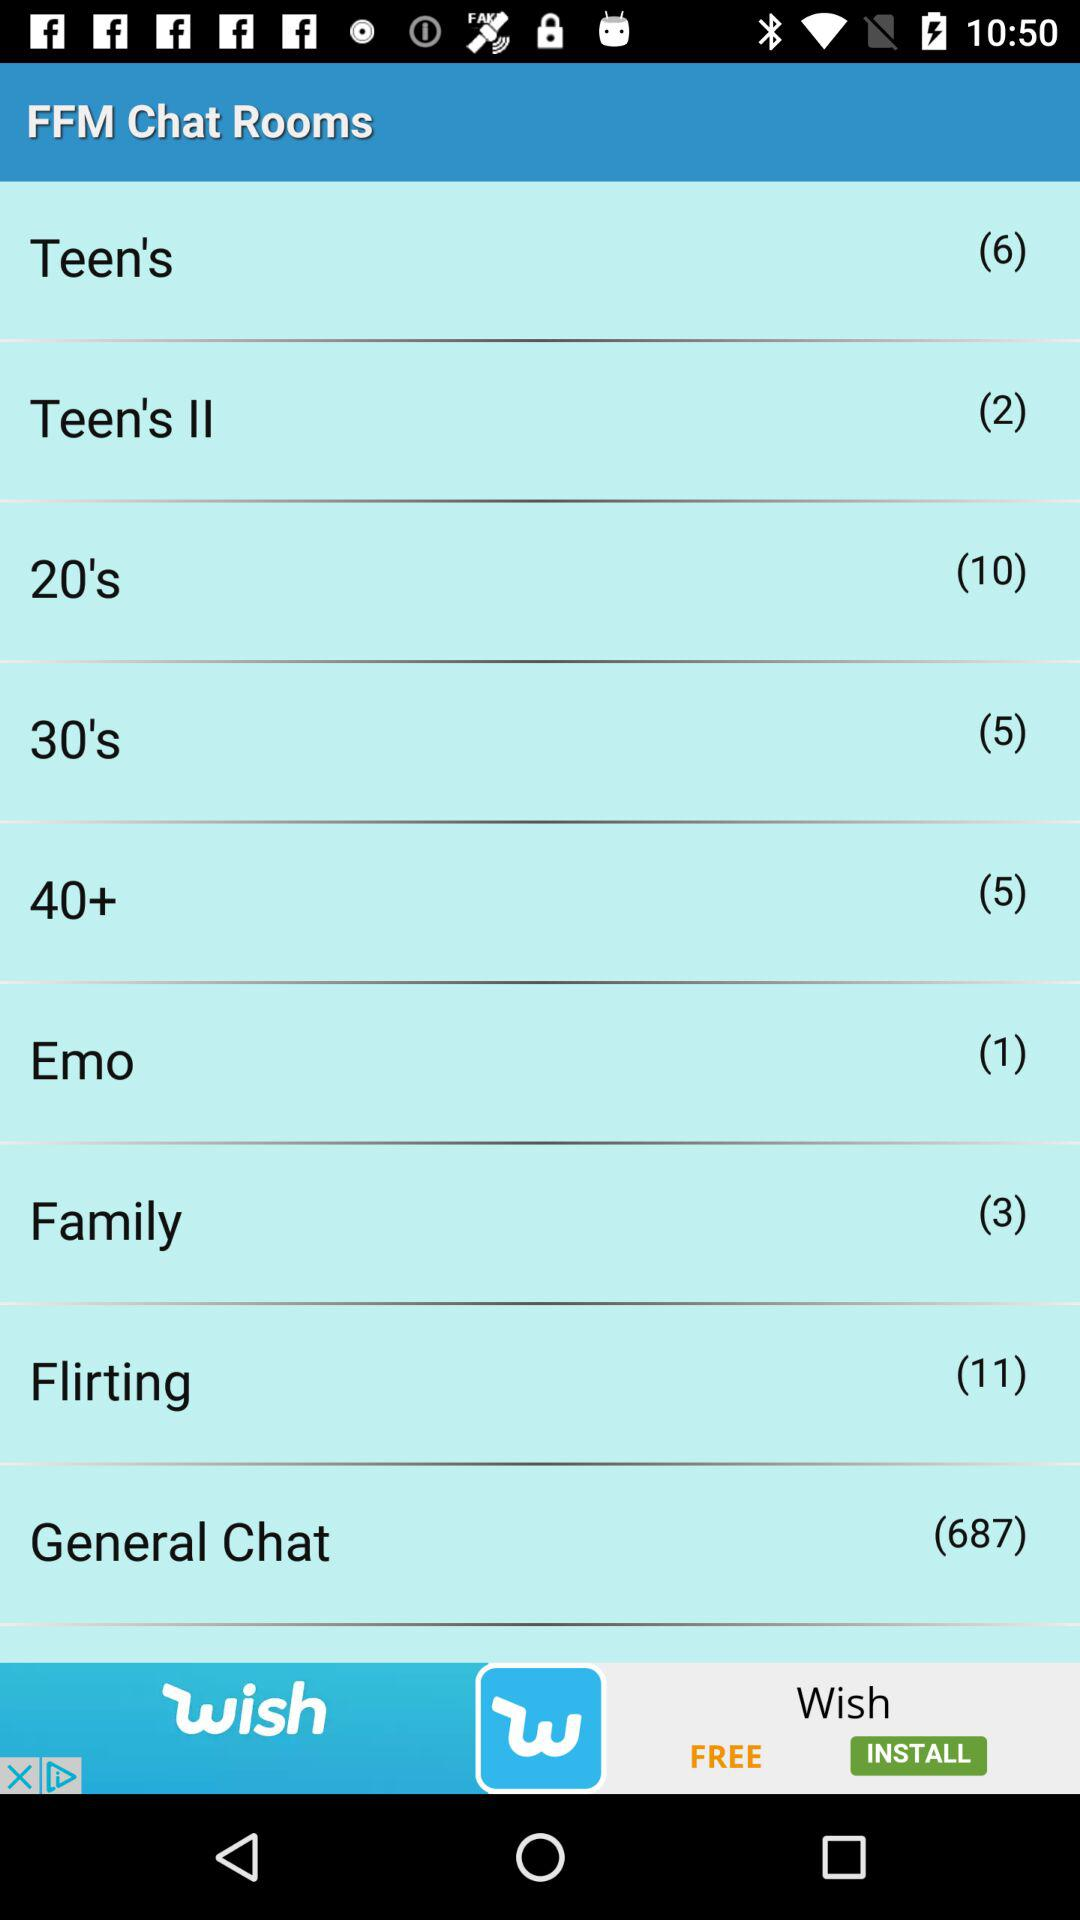What is the name of the application? The name of the application is "FFM Chat Rooms". 